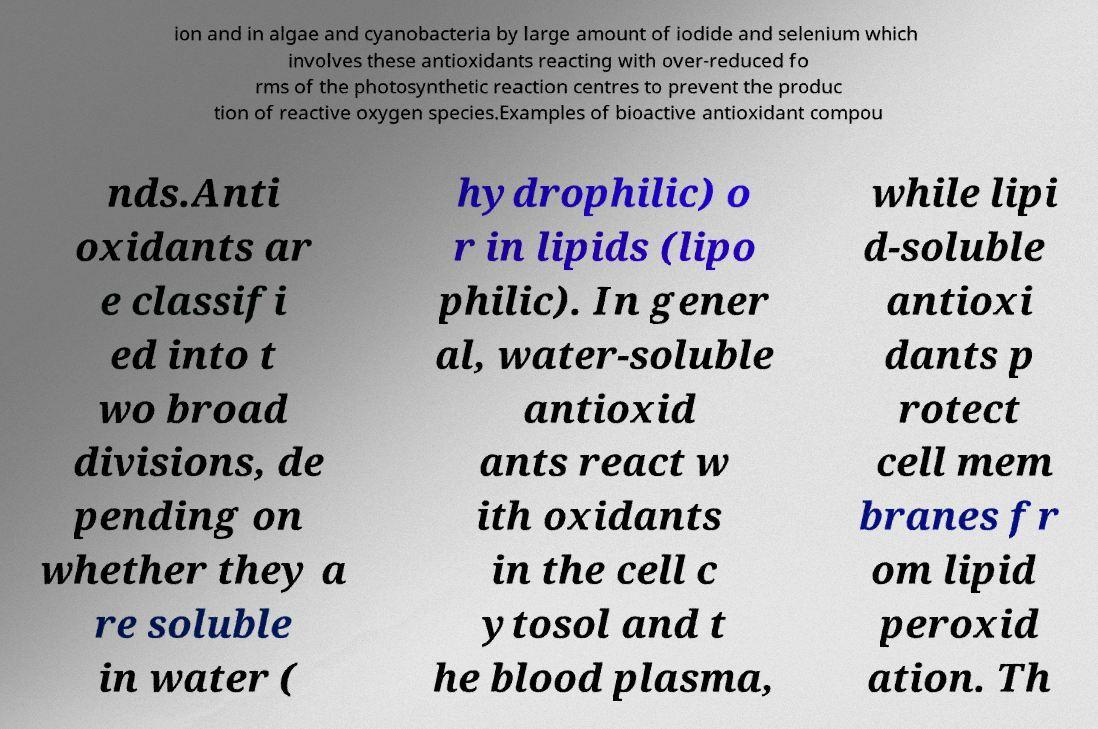Can you accurately transcribe the text from the provided image for me? ion and in algae and cyanobacteria by large amount of iodide and selenium which involves these antioxidants reacting with over-reduced fo rms of the photosynthetic reaction centres to prevent the produc tion of reactive oxygen species.Examples of bioactive antioxidant compou nds.Anti oxidants ar e classifi ed into t wo broad divisions, de pending on whether they a re soluble in water ( hydrophilic) o r in lipids (lipo philic). In gener al, water-soluble antioxid ants react w ith oxidants in the cell c ytosol and t he blood plasma, while lipi d-soluble antioxi dants p rotect cell mem branes fr om lipid peroxid ation. Th 